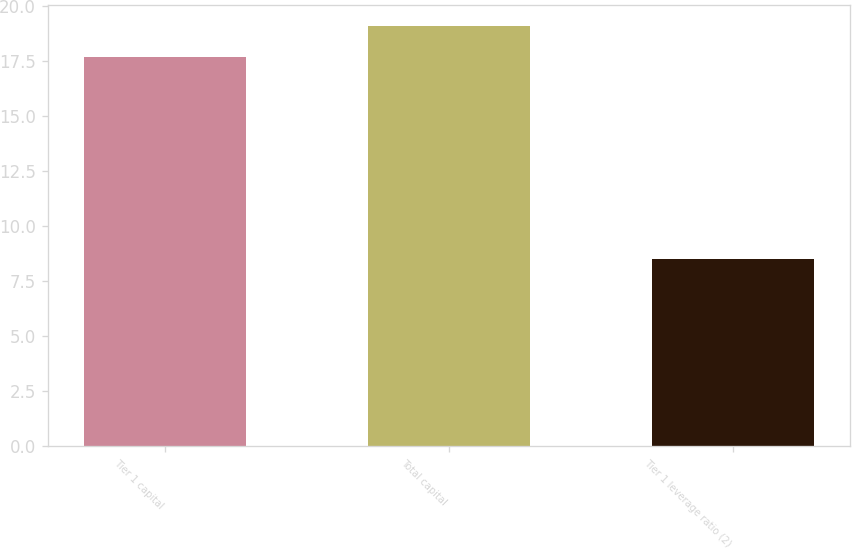Convert chart. <chart><loc_0><loc_0><loc_500><loc_500><bar_chart><fcel>Tier 1 capital<fcel>Total capital<fcel>Tier 1 leverage ratio (2)<nl><fcel>17.7<fcel>19.1<fcel>8.5<nl></chart> 